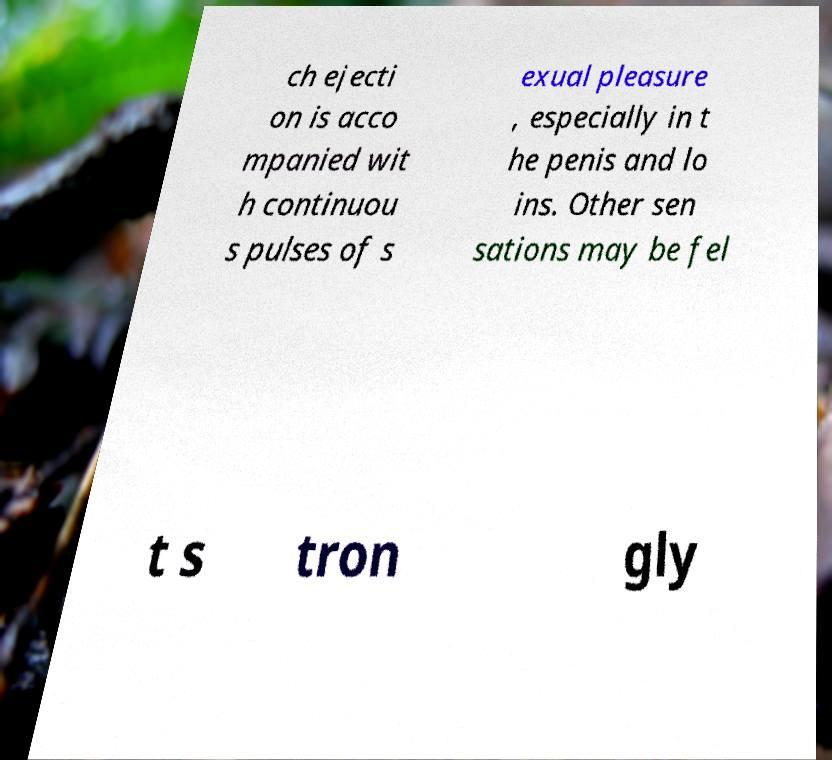Can you accurately transcribe the text from the provided image for me? ch ejecti on is acco mpanied wit h continuou s pulses of s exual pleasure , especially in t he penis and lo ins. Other sen sations may be fel t s tron gly 